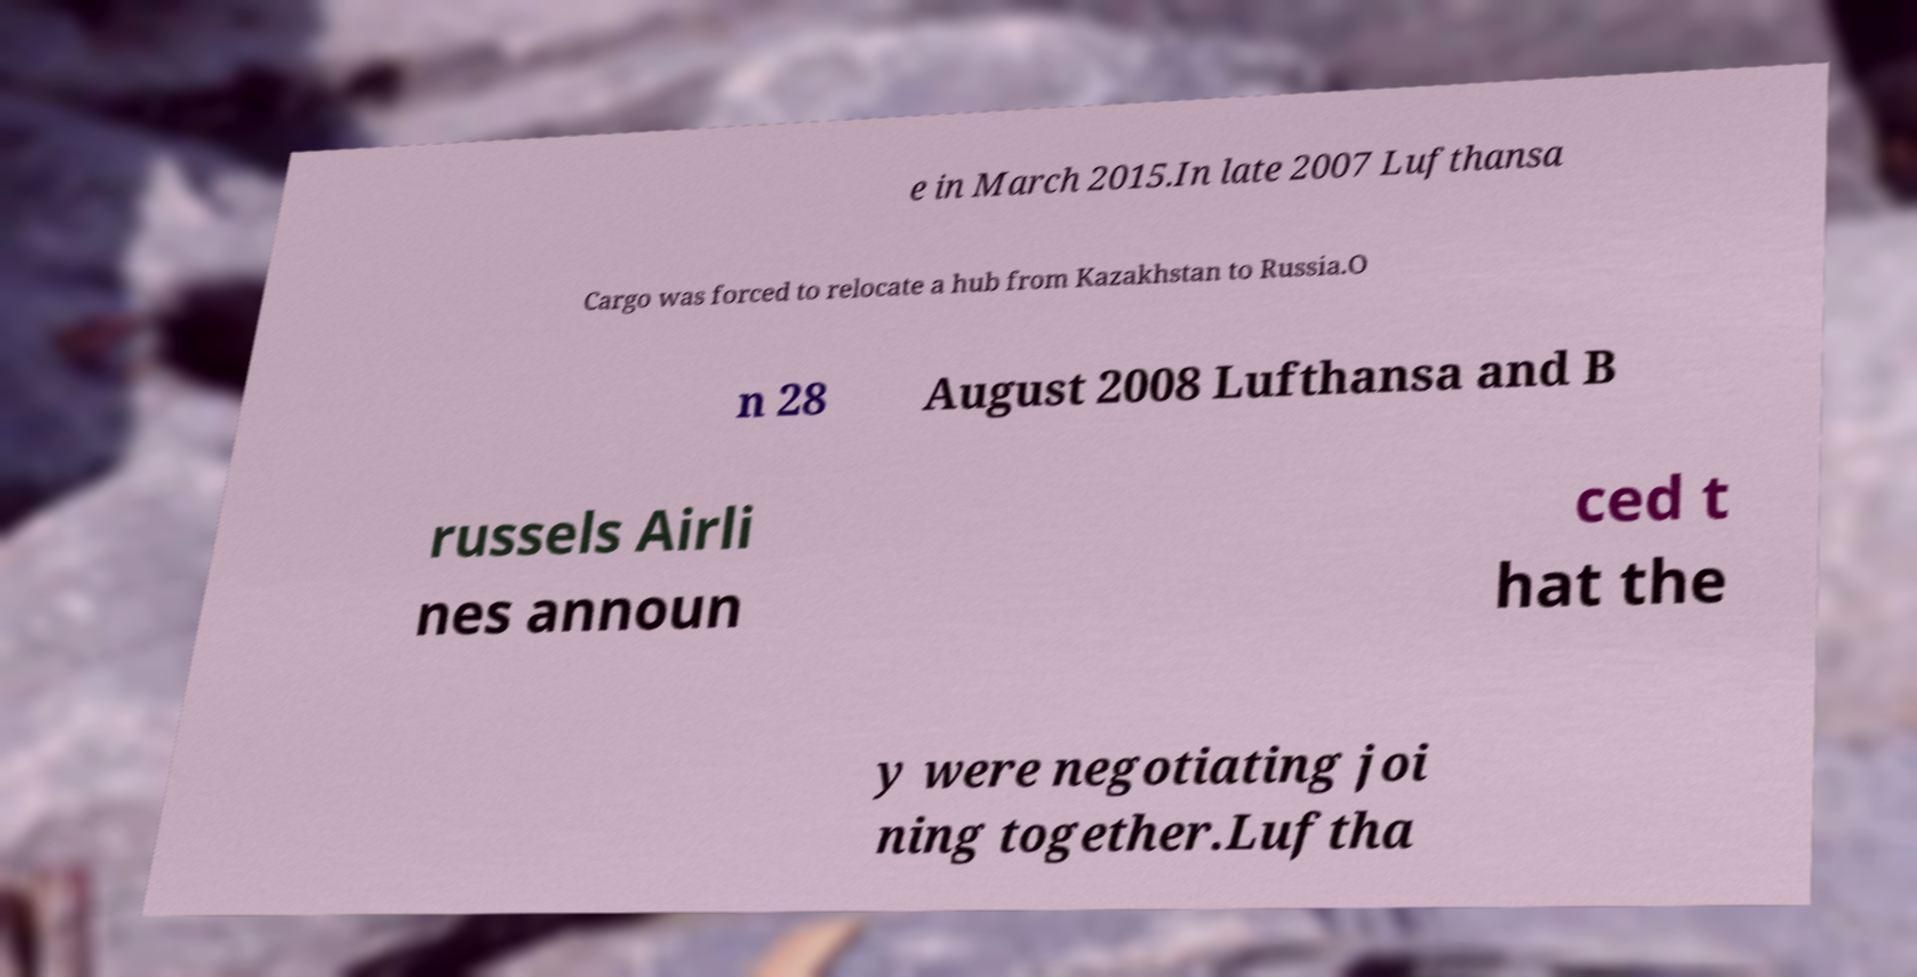There's text embedded in this image that I need extracted. Can you transcribe it verbatim? e in March 2015.In late 2007 Lufthansa Cargo was forced to relocate a hub from Kazakhstan to Russia.O n 28 August 2008 Lufthansa and B russels Airli nes announ ced t hat the y were negotiating joi ning together.Luftha 